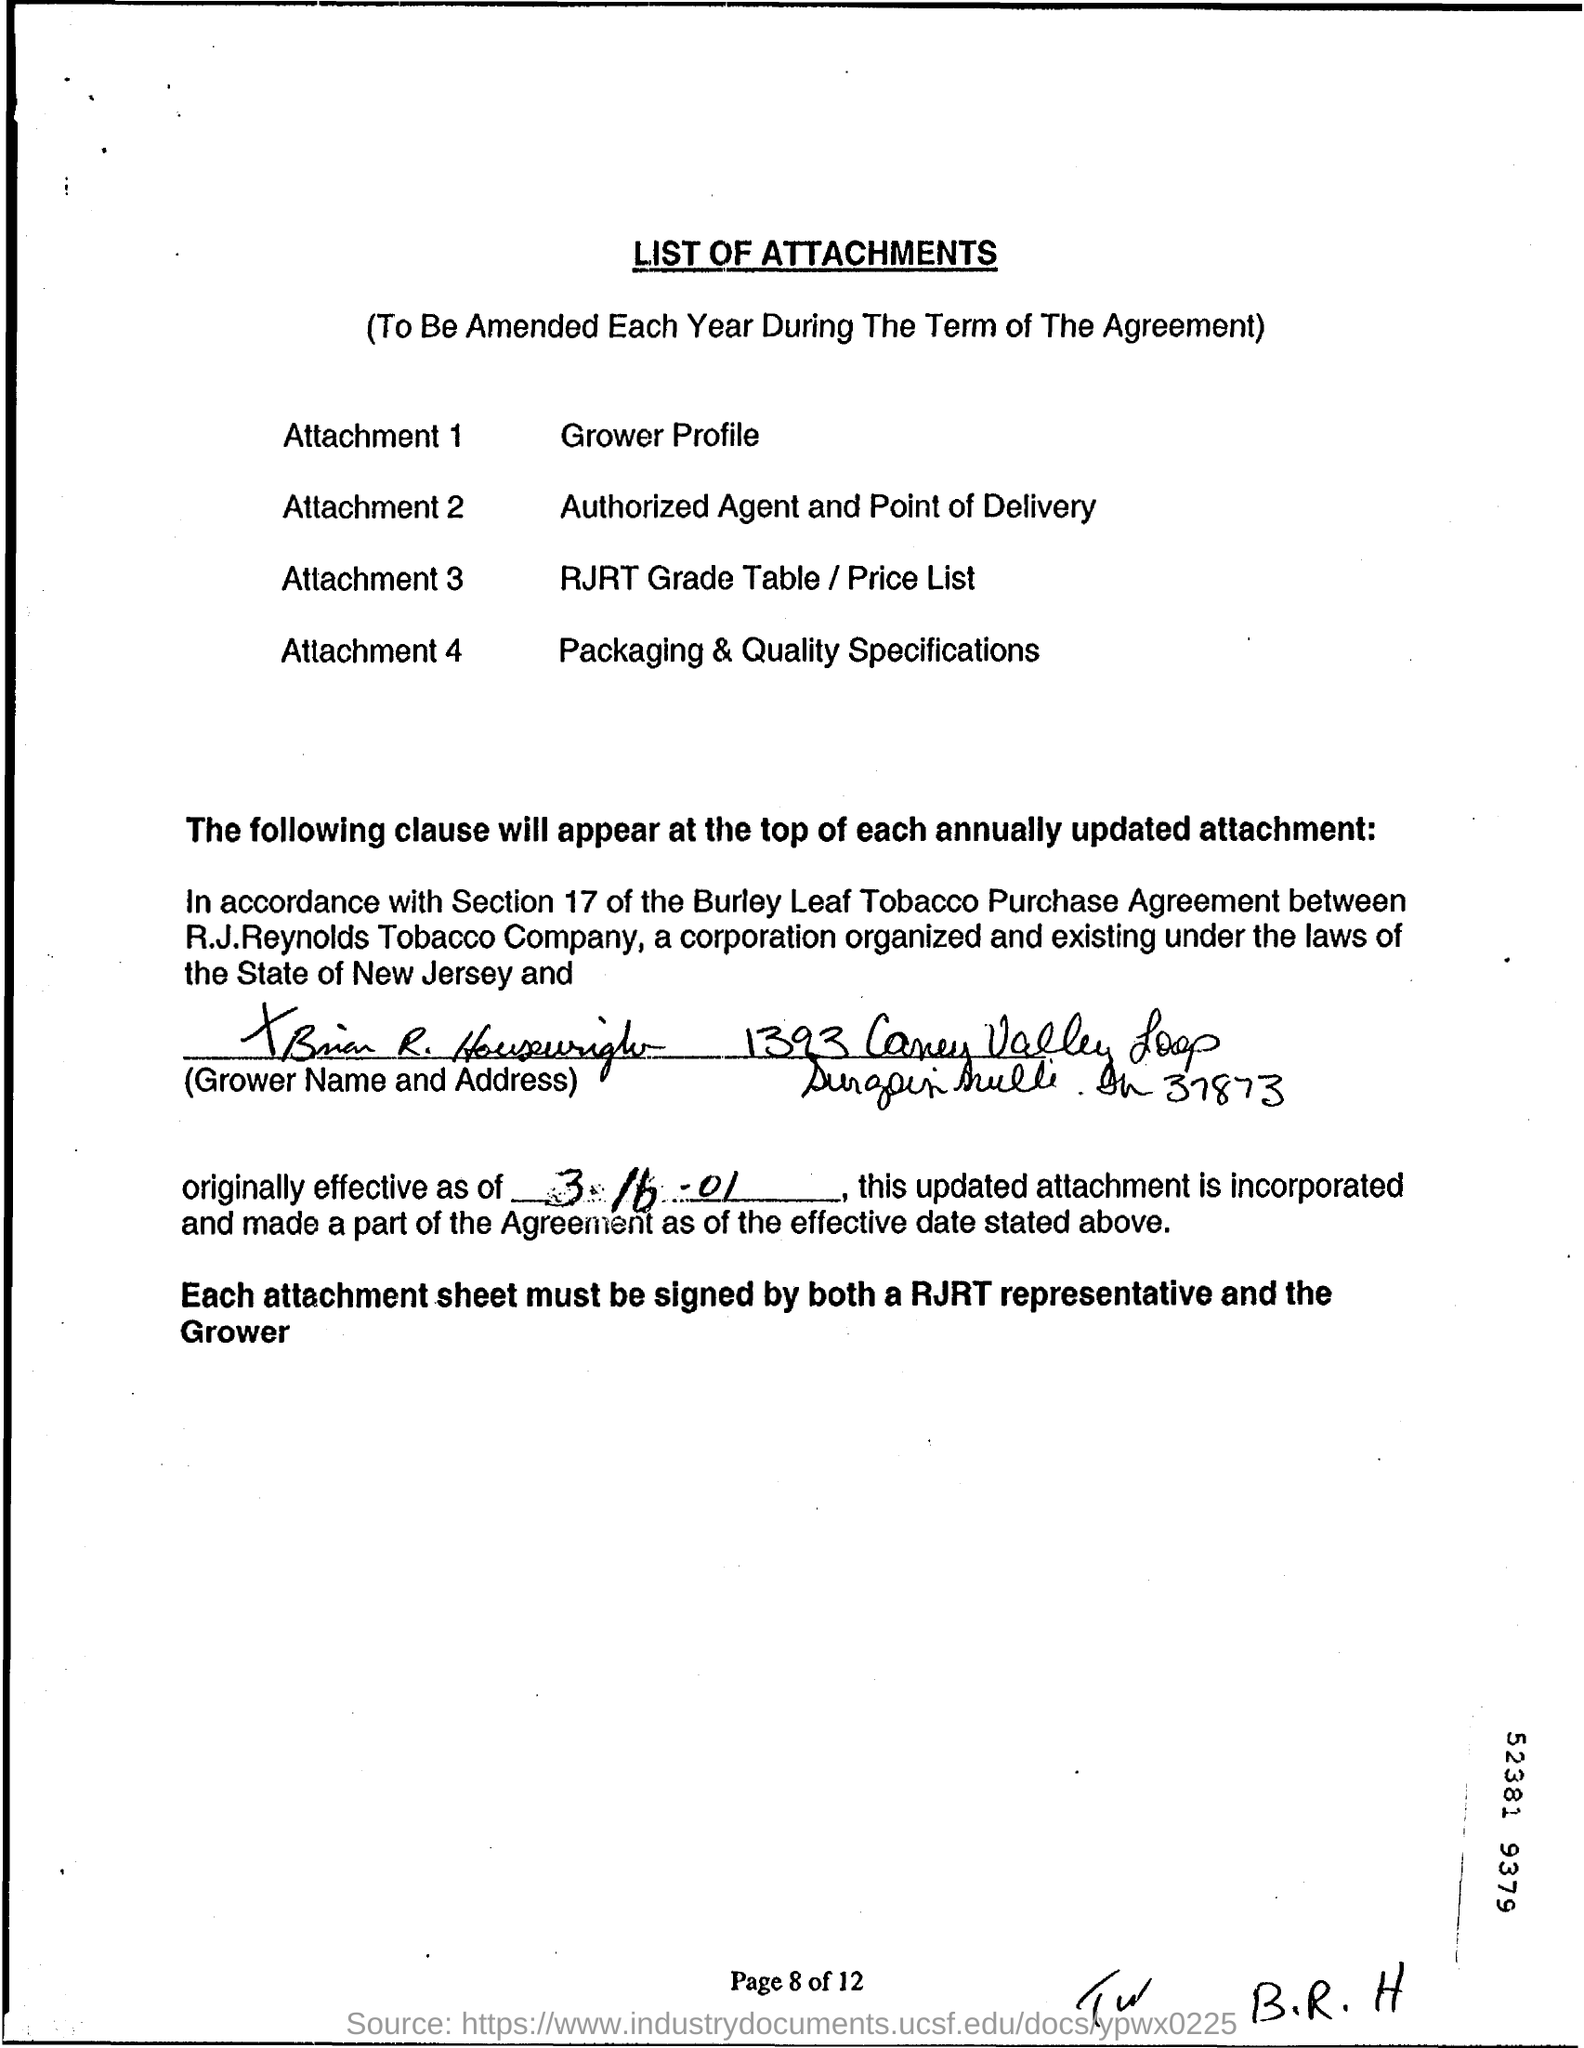List a handful of essential elements in this visual. The signatories for each attachment sheet are a representative of RJRT and the grower. The document title is LIST OF ATTACHMENTS. Attachment 2 refers to the authorized agent and point of delivery for the transportation of hazardous materials. The agreement is effective as of March 16, 2001. The page number is 8 out of 12. 